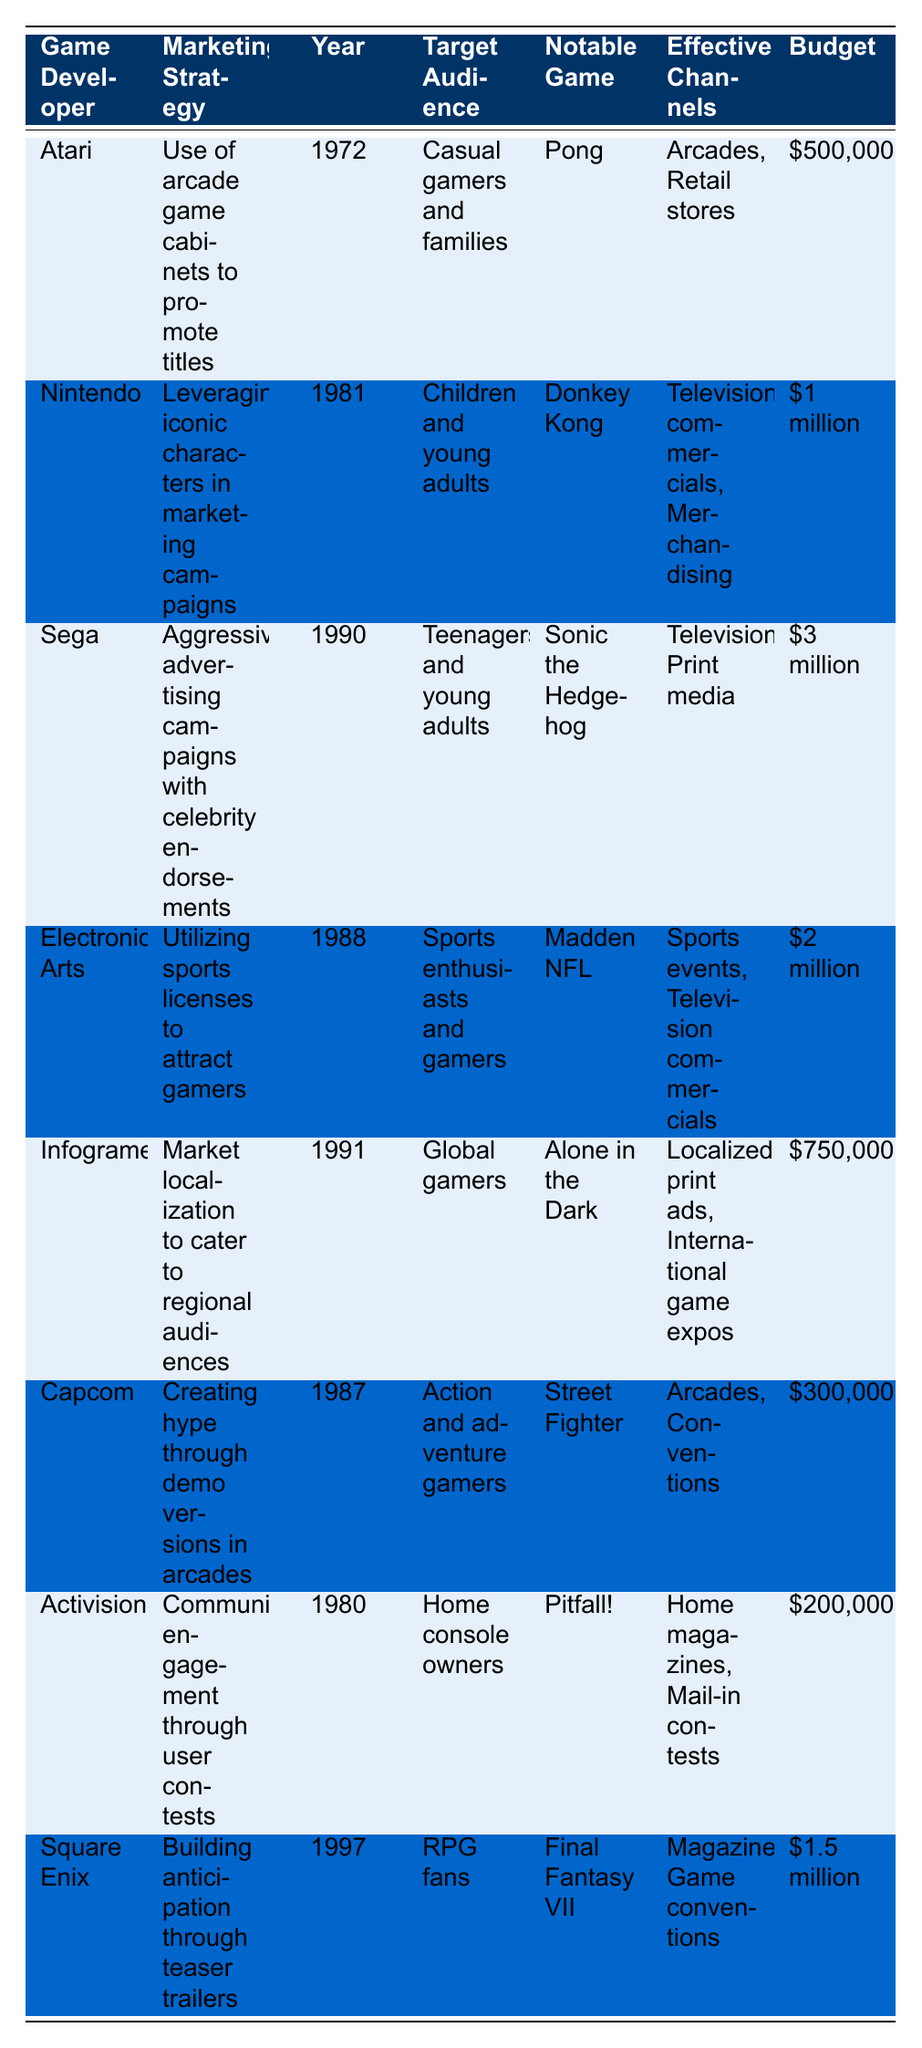What marketing strategy did Atari use? The table lists Atari's marketing strategy as the use of arcade game cabinets to promote titles.
Answer: Use of arcade game cabinets to promote titles Which notable game was marketed by Sega in 1990? According to the table, the notable game marketed by Sega in 1990 is Sonic the Hedgehog.
Answer: Sonic the Hedgehog What was the target audience for Nintendo's marketing strategy in 1981? The table indicates that Nintendo's target audience in 1981 was children and young adults.
Answer: Children and young adults Which game developer had the highest marketing budget, and what was it? By reviewing the budget column, Sega had the highest budget of $3 million in 1990.
Answer: Sega; $3 million Did Infogrames use international game expos as an effective channel in their marketing strategy? The table shows that Infogrames included international game expos as one of their effective channels.
Answer: Yes How much did Activision spend on their marketing strategy? The table shows that Activision's marketing budget was $200,000.
Answer: $200,000 In which year did Square Enix market Final Fantasy VII? According to the table, Square Enix marketed Final Fantasy VII in 1997.
Answer: 1997 What is the average budget spent by the game developers listed in the table? The budgets are $500,000, $1,000,000, $3,000,000, $2,000,000, $750,000, $300,000, $200,000, and $1,500,000. Summing these gives $9,250,000, and dividing by 8 developers results in an average of $1,156,250.
Answer: $1,156,250 What effective channels did Electronic Arts use in their marketing strategy? The table indicates that Electronic Arts used sports events and television commercials as effective channels.
Answer: Sports events and television commercials Is the target audience for Capcom's marketing strategy identical to that of Sega's? By comparing the target audiences listed, it is clear that Capcom targets action and adventure gamers while Sega targets teenagers and young adults, thus they are not identical.
Answer: No What marketing strategy did Activision employ in 1980? The table notes that Activision's marketing strategy in 1980 was community engagement through user contests.
Answer: Community engagement through user contests 